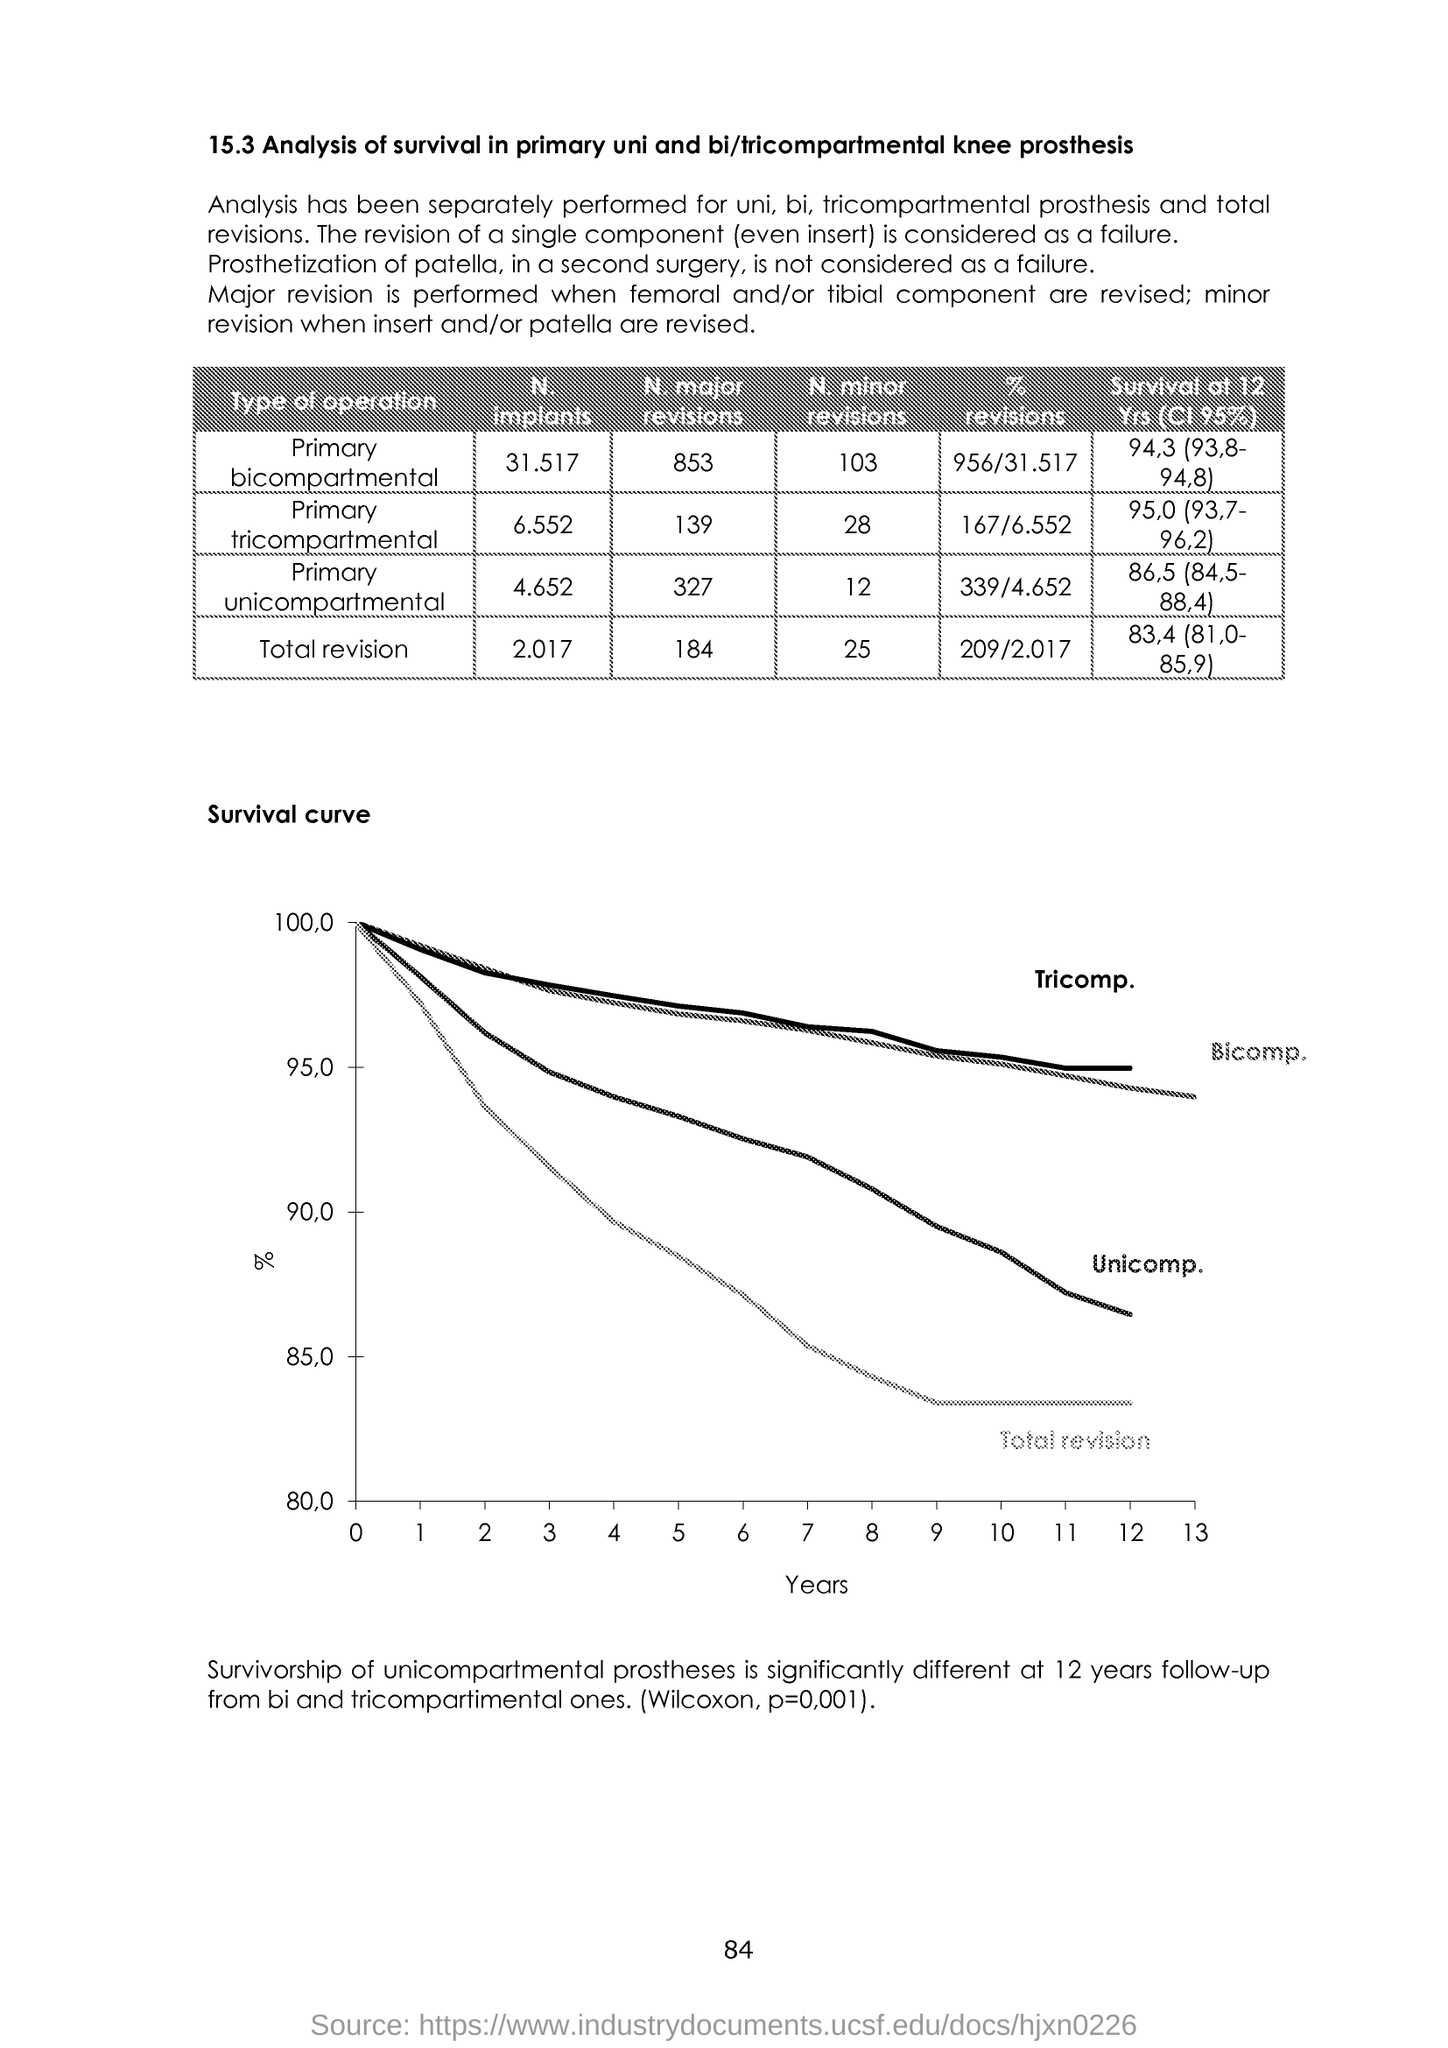How does this data impact the choice of knee prosthesis for surgery? Data like this can significantly influence the decision-making process for selecting the type of knee prosthesis for surgery. Factors such as the patient's age, activity level, and the affected knee compartments would be considered alongside these survivability rates. Surgeons and patients may prefer a prosthesis type with a higher survivability rate to potentially reduce the likelihood of future revision surgeries. However, individual patient circumstances and prosthesis performance must be assessed on a case-by-case basis. 